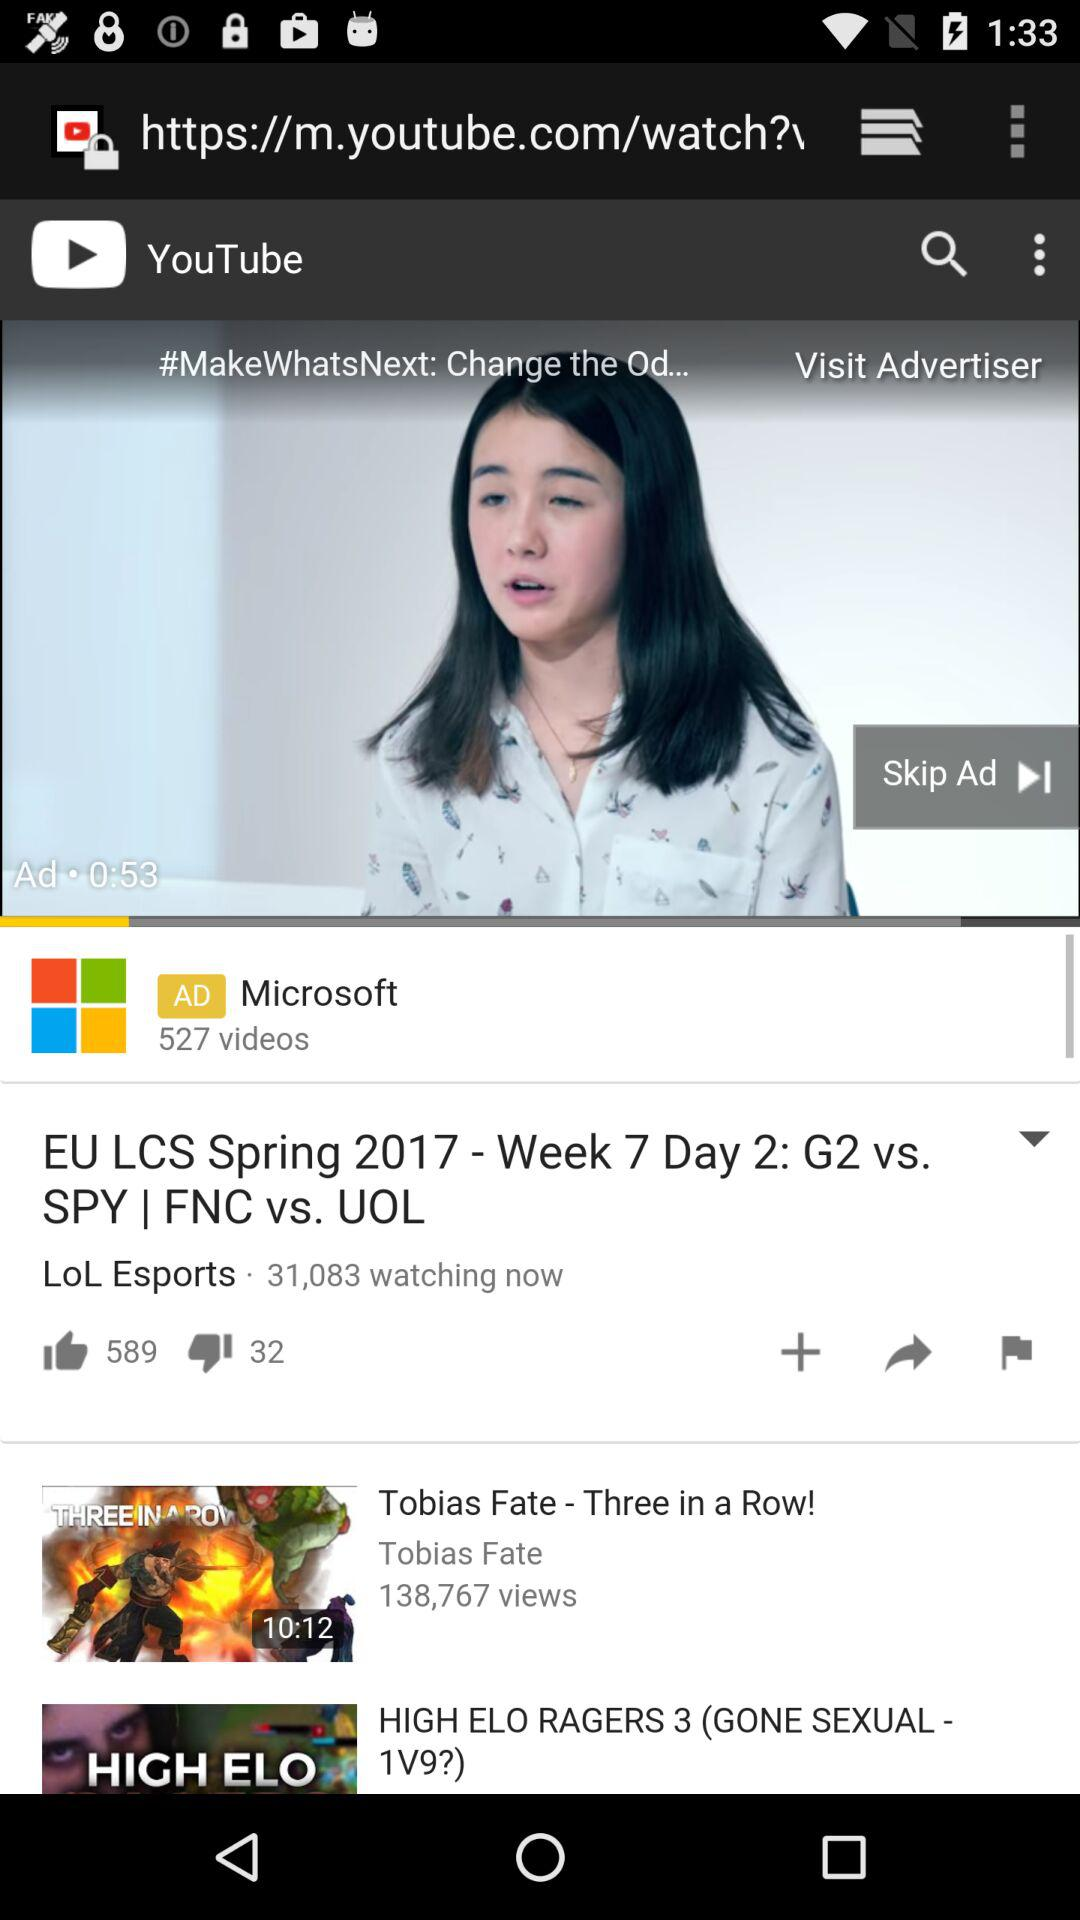What is the duration of the "Tobias Fate - Three in a Row!" video? The duration of the "Tobias Fate - Three in a Row!" video is 10 minutes and 12 seconds. 